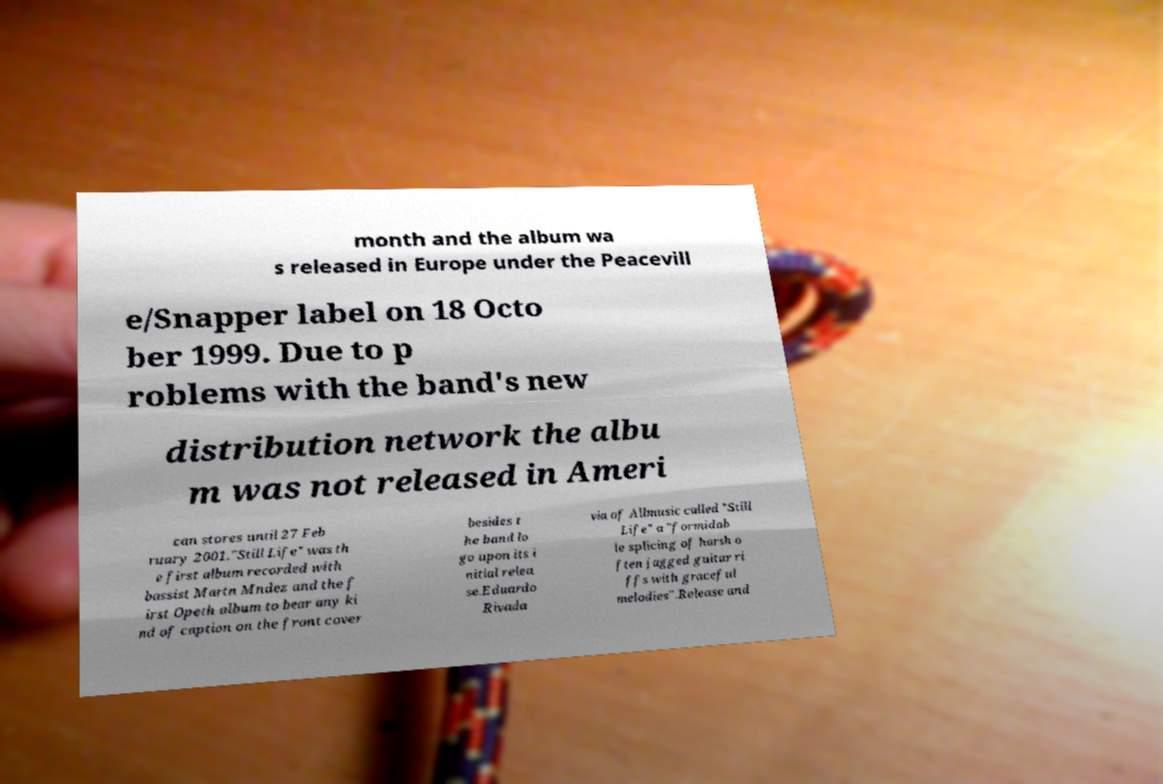What messages or text are displayed in this image? I need them in a readable, typed format. month and the album wa s released in Europe under the Peacevill e/Snapper label on 18 Octo ber 1999. Due to p roblems with the band's new distribution network the albu m was not released in Ameri can stores until 27 Feb ruary 2001."Still Life" was th e first album recorded with bassist Martn Mndez and the f irst Opeth album to bear any ki nd of caption on the front cover besides t he band lo go upon its i nitial relea se.Eduardo Rivada via of Allmusic called "Still Life" a "formidab le splicing of harsh o ften jagged guitar ri ffs with graceful melodies".Release and 